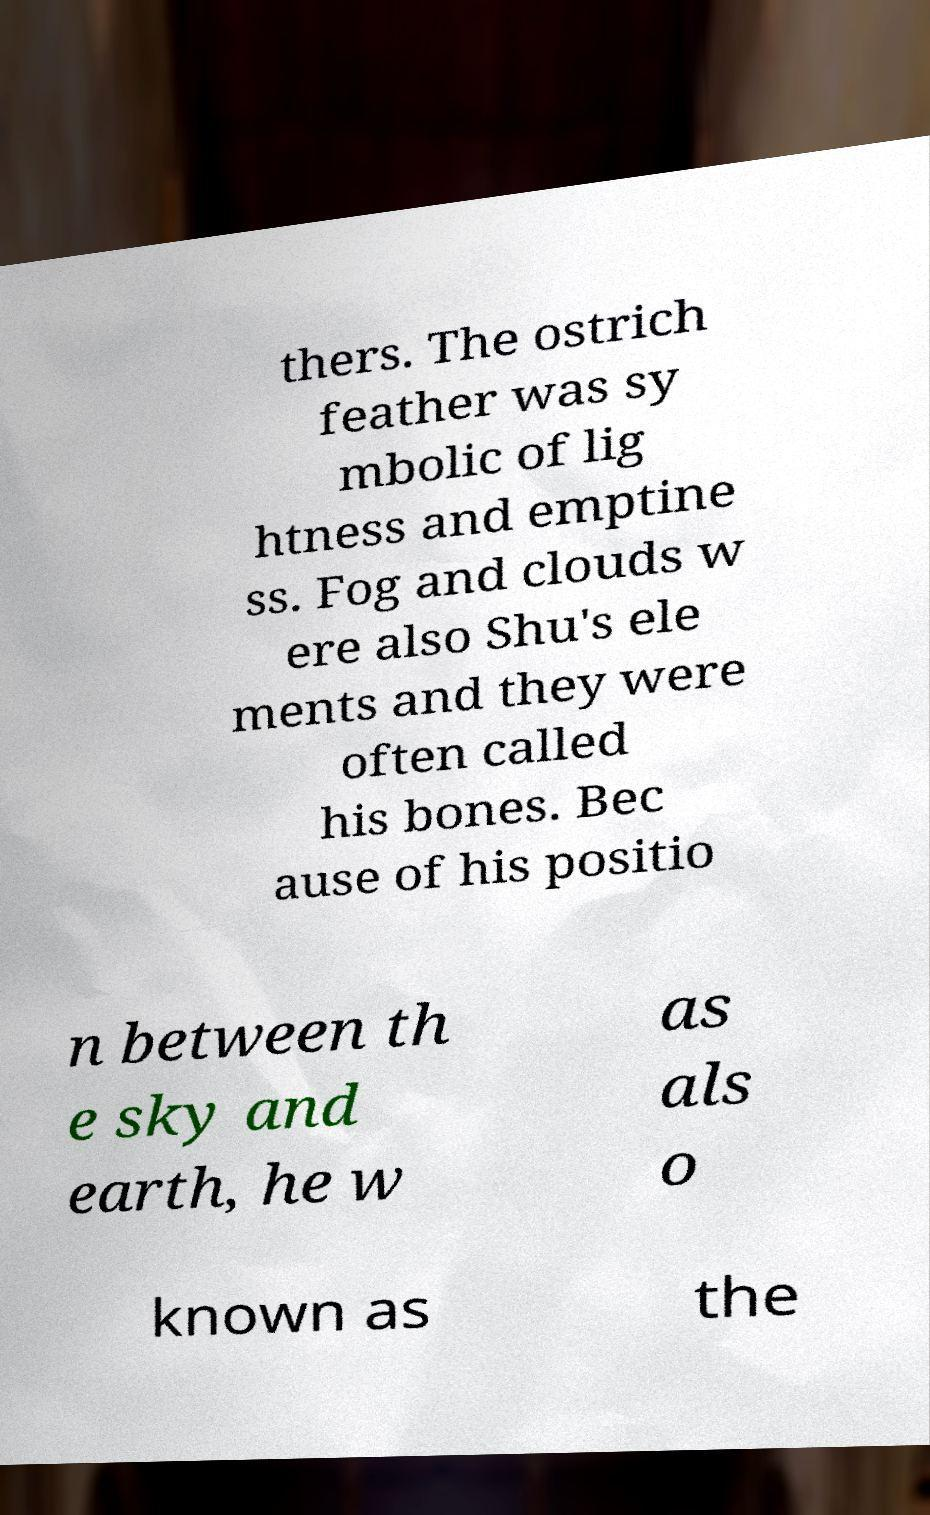I need the written content from this picture converted into text. Can you do that? thers. The ostrich feather was sy mbolic of lig htness and emptine ss. Fog and clouds w ere also Shu's ele ments and they were often called his bones. Bec ause of his positio n between th e sky and earth, he w as als o known as the 